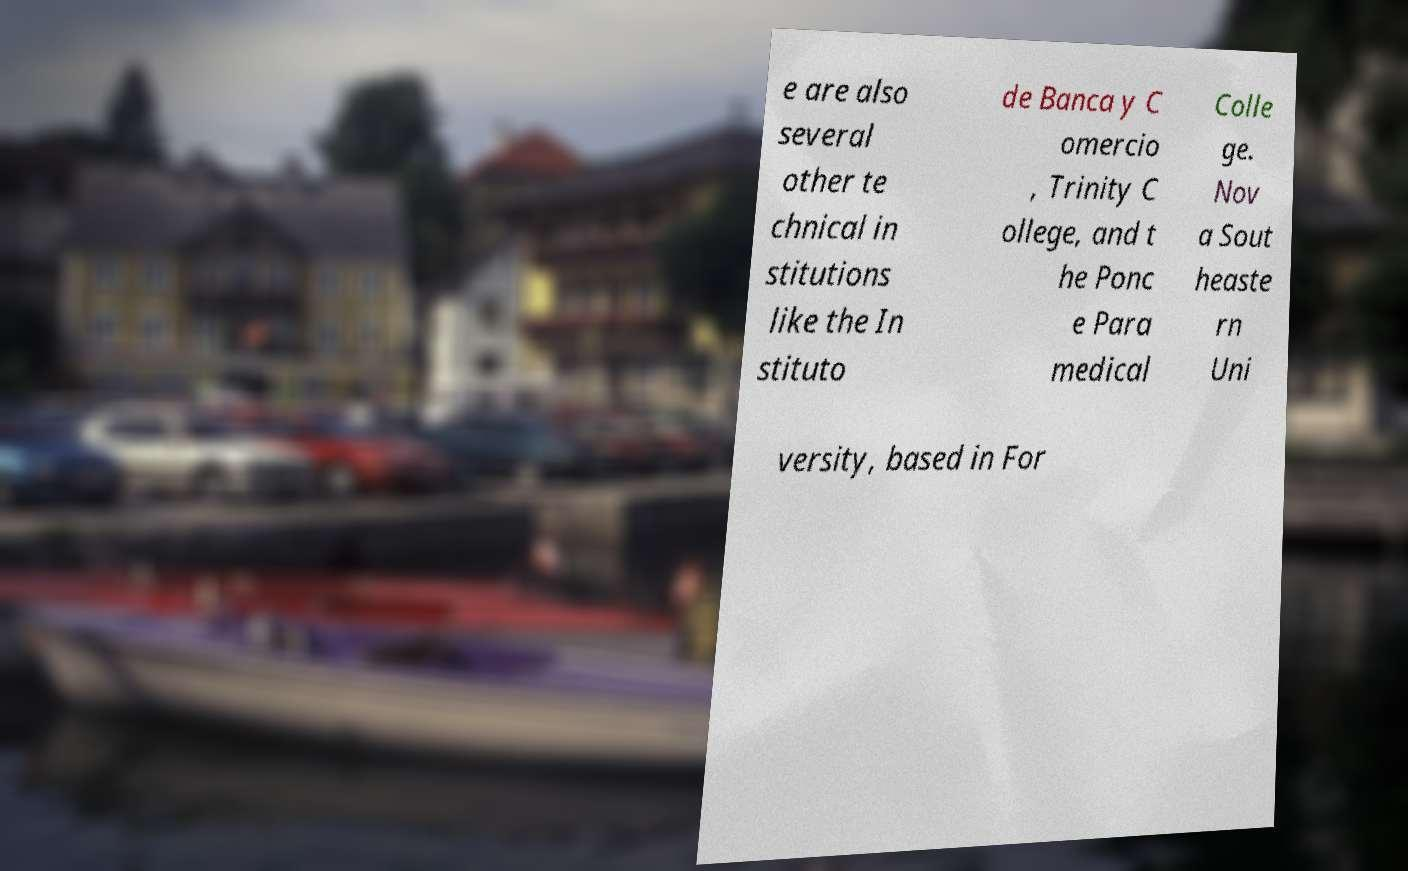Can you accurately transcribe the text from the provided image for me? e are also several other te chnical in stitutions like the In stituto de Banca y C omercio , Trinity C ollege, and t he Ponc e Para medical Colle ge. Nov a Sout heaste rn Uni versity, based in For 